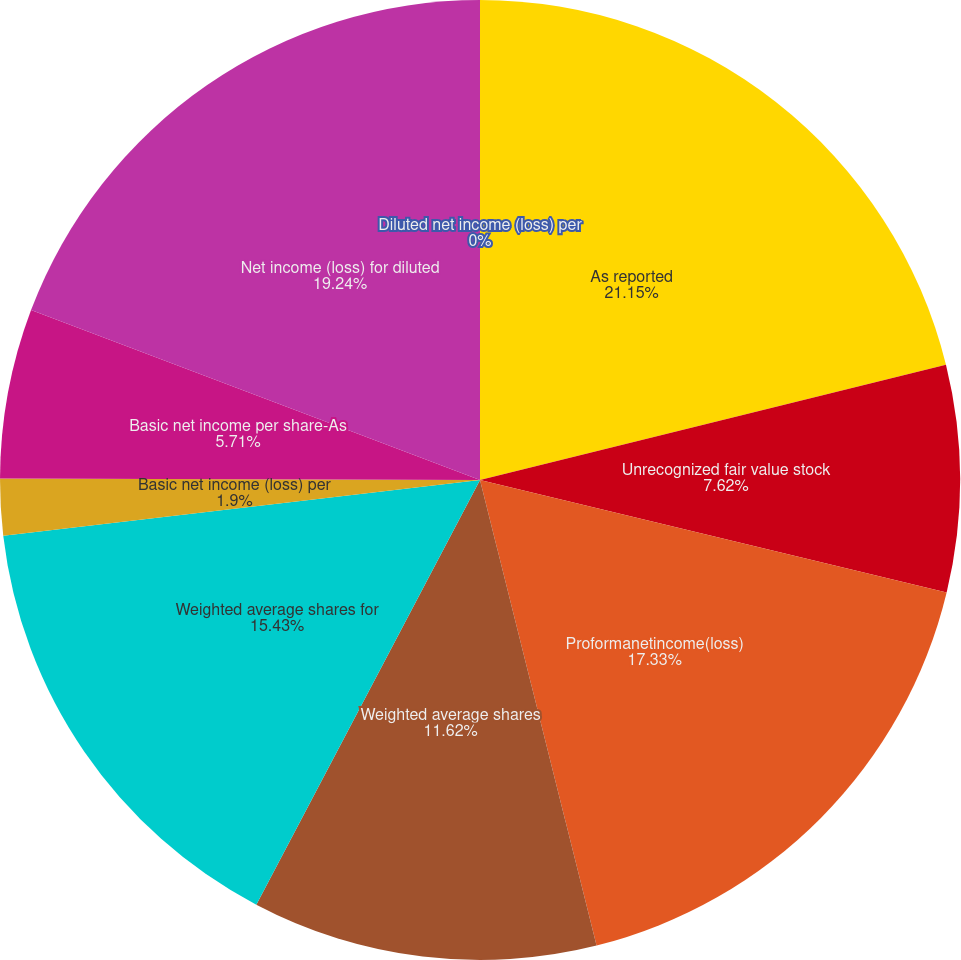<chart> <loc_0><loc_0><loc_500><loc_500><pie_chart><fcel>As reported<fcel>Unrecognized fair value stock<fcel>Proformanetincome(loss)<fcel>Weighted average shares<fcel>Weighted average shares for<fcel>Basic net income (loss) per<fcel>Basic net income per share-As<fcel>Net income (loss) for diluted<fcel>Diluted net income (loss) per<nl><fcel>21.14%<fcel>7.62%<fcel>17.33%<fcel>11.62%<fcel>15.43%<fcel>1.9%<fcel>5.71%<fcel>19.24%<fcel>0.0%<nl></chart> 